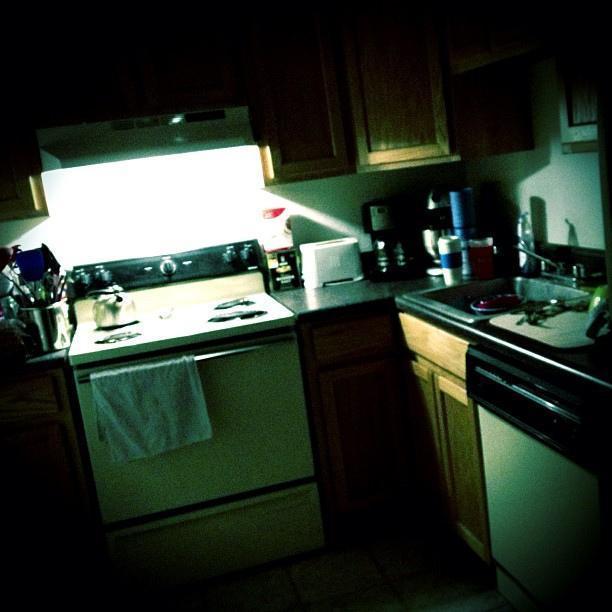How many sinks are visible?
Give a very brief answer. 2. 